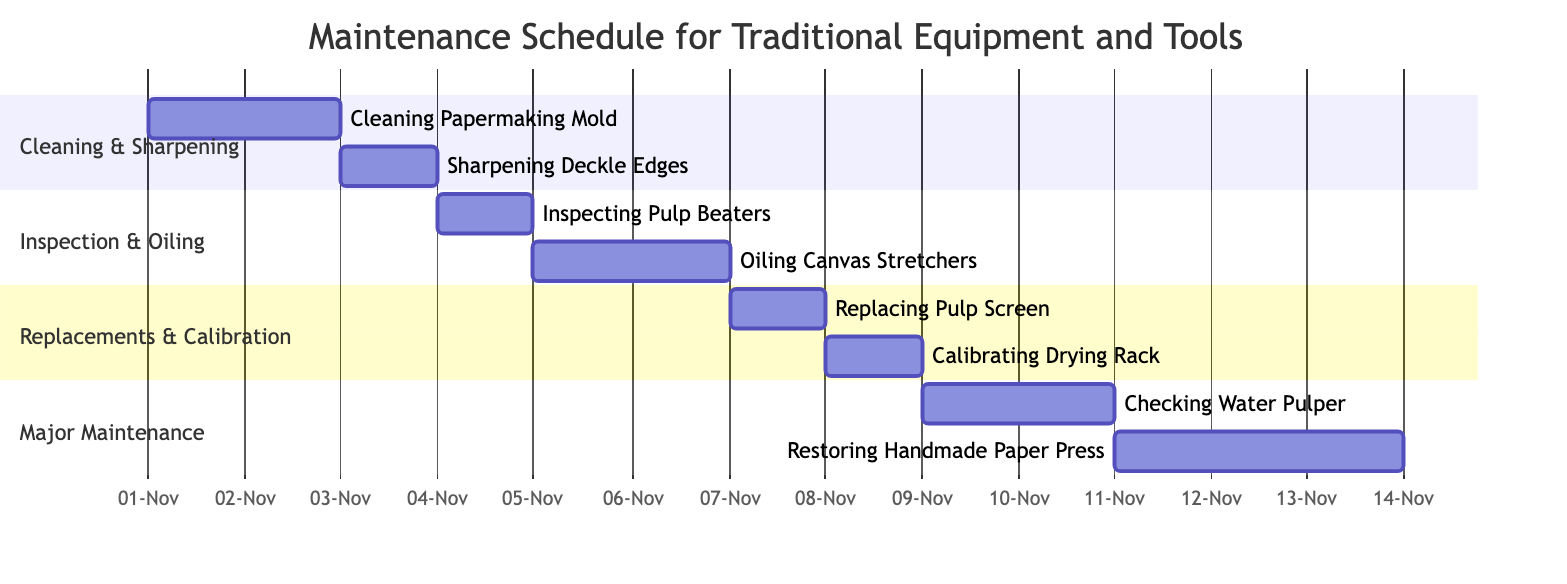What is the duration for cleaning the papermaking mold? According to the diagram, the task "Cleaning Papermaking Mold" has a duration of '2 days'. This information is indicated right next to the task’s name within the Gantt Chart.
Answer: 2 days When does the maintenance of the canvas stretchers start? The task "Oiling Canvas Stretchers" starts on '2023-11-05' as indicated in the Gantt Chart, which shows the start date aligned with the specific task.
Answer: 2023-11-05 How many total maintenance tasks are scheduled? By counting the tasks listed in all sections of the Gantt Chart, there are a total of '8' tasks scheduled for maintenance. Each task is represented as a distinct entry.
Answer: 8 Which task follows the inspection of the pulp beaters? The task "Oiling Canvas Stretchers", which is shown in the diagram immediately after "Inspecting Pulp Beaters", follows it in the timeline. The start date for "Oiling Canvas Stretchers" is '2023-11-05', the day after "Inspecting Pulp Beaters".
Answer: Oiling Canvas Stretchers What tasks overlap in terms of their duration? The tasks "Checking Water Pulper" and "Restoring Handmade Paper Press" overlap, as the former starts on '2023-11-09' and the latter starts on '2023-11-11', meaning they are conducted simultaneously for part of their durations.
Answer: Checking Water Pulper, Restoring Handmade Paper Press What task has the longest duration? In the Gantt Chart, "Restoring Handmade Paper Press" has a duration of '3 days', which is the longest duration of all the listed tasks. This can be identified by looking at the duration values next to each task.
Answer: Restoring Handmade Paper Press Which task is scheduled immediately after replacing the pulp screen? The next scheduled task after "Replacing Pulp Screen", which starts on '2023-11-07', is "Calibrating Drying Rack", beginning on '2023-11-08', according to the sequential arrangement of tasks in the Gantt Chart.
Answer: Calibrating Drying Rack In which section does the task of cleaning the papermaking mold fall? The task "Cleaning Papermaking Mold" is categorized under the section called "Cleaning & Sharpening" as shown in the diagram's organization of tasks into thematic sections.
Answer: Cleaning & Sharpening 